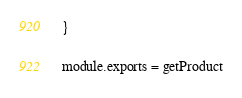<code> <loc_0><loc_0><loc_500><loc_500><_JavaScript_>}

module.exports = getProduct
</code> 